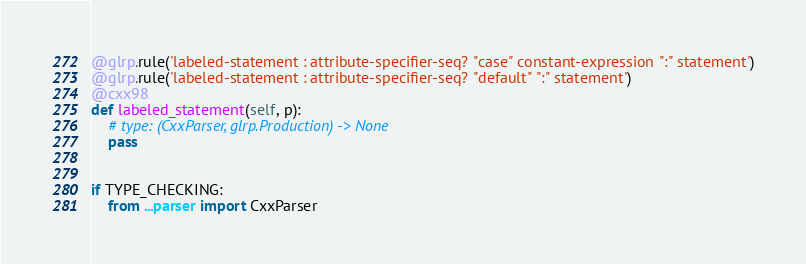<code> <loc_0><loc_0><loc_500><loc_500><_Python_>@glrp.rule('labeled-statement : attribute-specifier-seq? "case" constant-expression ":" statement')
@glrp.rule('labeled-statement : attribute-specifier-seq? "default" ":" statement')
@cxx98
def labeled_statement(self, p):
    # type: (CxxParser, glrp.Production) -> None
    pass


if TYPE_CHECKING:
    from ...parser import CxxParser</code> 